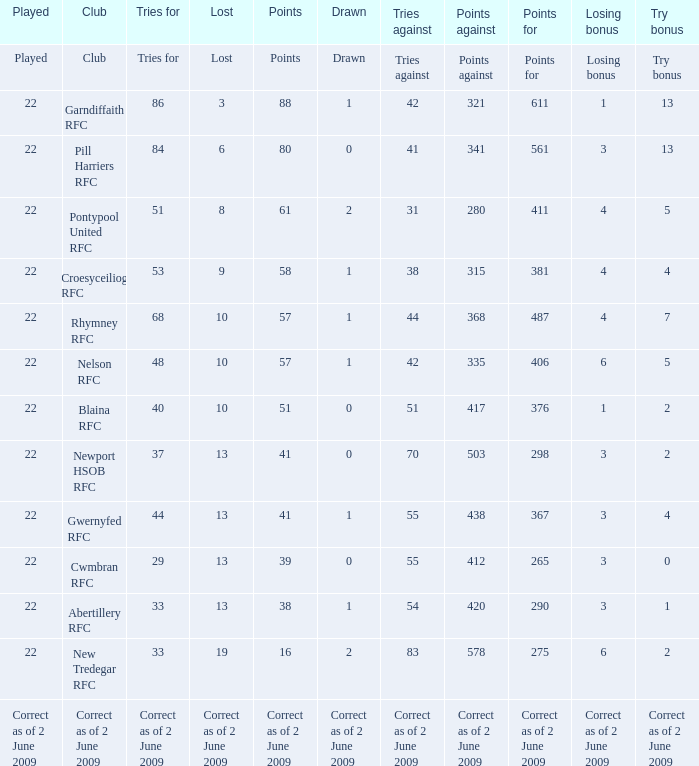How many tries did the club with a try bonus of correct as of 2 June 2009 have? Correct as of 2 June 2009. 